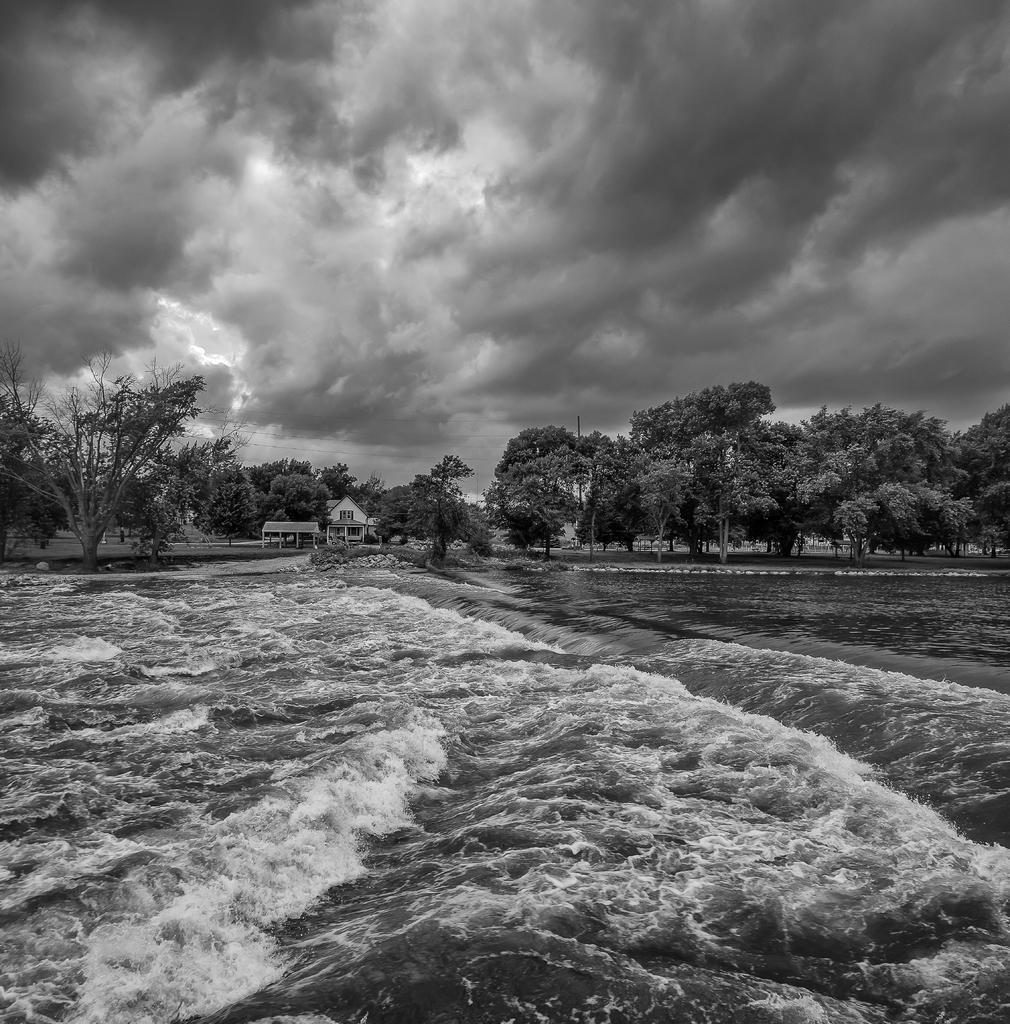What type of structure is present in the image? There is a house in the image. What natural elements can be seen in the image? There are trees and waves visible in the image. What is the condition of the sky in the image? The sky is cloudy in the image. What type of bell can be heard ringing in the image? There is no bell present in the image, and therefore no sound can be heard. Is there a hammer visible in the image? There is no hammer present in the image. 